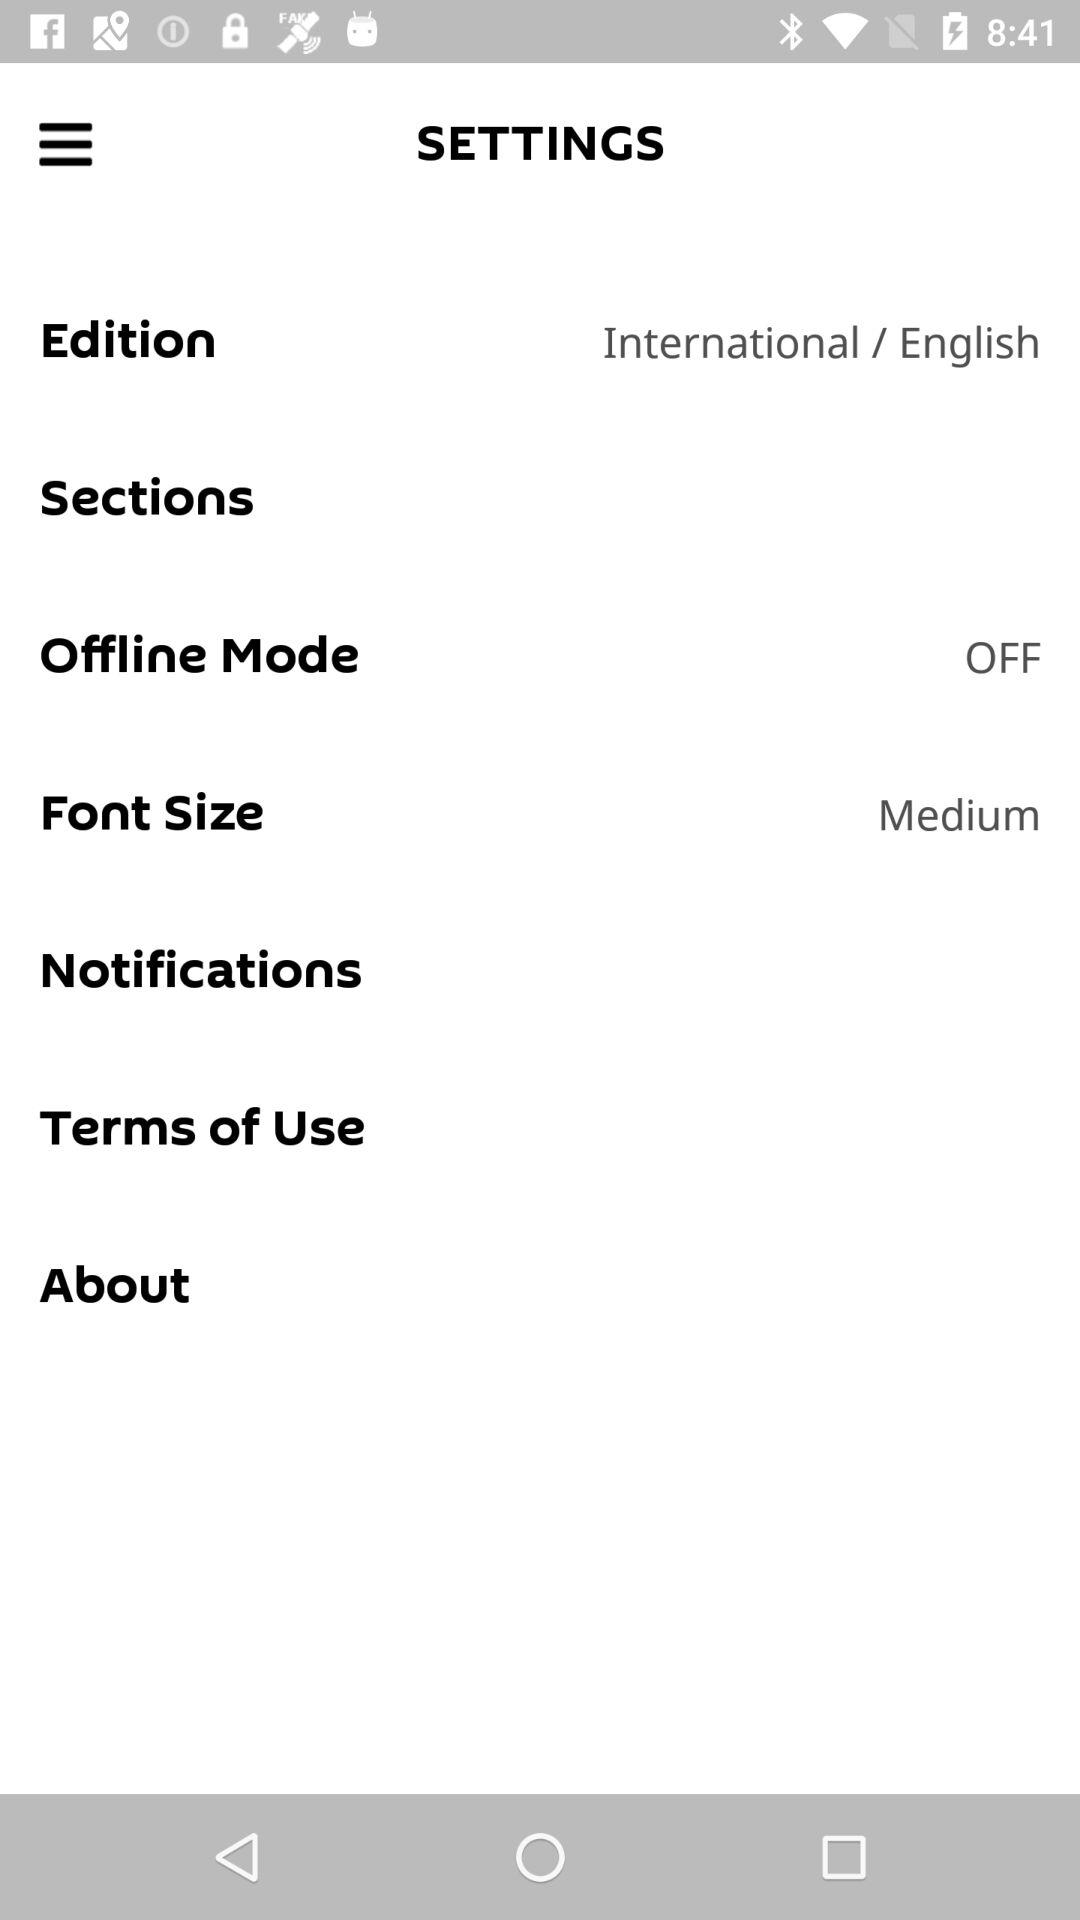How big is the font size in points?
When the provided information is insufficient, respond with <no answer>. <no answer> 